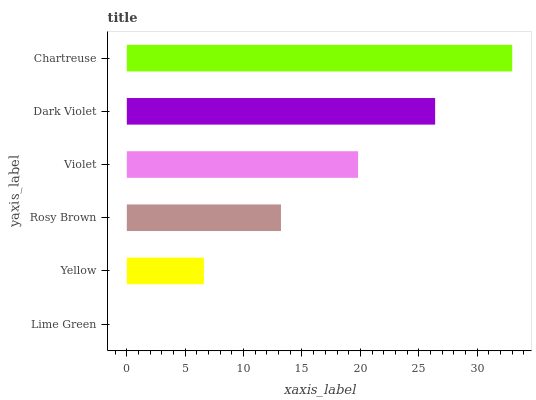Is Lime Green the minimum?
Answer yes or no. Yes. Is Chartreuse the maximum?
Answer yes or no. Yes. Is Yellow the minimum?
Answer yes or no. No. Is Yellow the maximum?
Answer yes or no. No. Is Yellow greater than Lime Green?
Answer yes or no. Yes. Is Lime Green less than Yellow?
Answer yes or no. Yes. Is Lime Green greater than Yellow?
Answer yes or no. No. Is Yellow less than Lime Green?
Answer yes or no. No. Is Violet the high median?
Answer yes or no. Yes. Is Rosy Brown the low median?
Answer yes or no. Yes. Is Lime Green the high median?
Answer yes or no. No. Is Lime Green the low median?
Answer yes or no. No. 